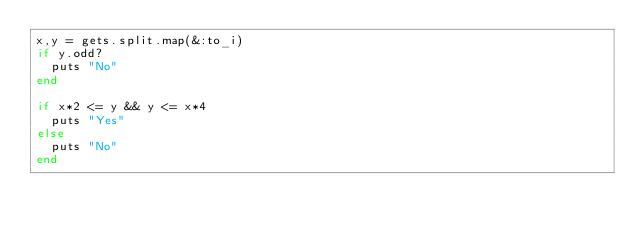Convert code to text. <code><loc_0><loc_0><loc_500><loc_500><_Ruby_>x,y = gets.split.map(&:to_i)
if y.odd?
  puts "No"
end

if x*2 <= y && y <= x*4
  puts "Yes"
else
  puts "No"
end
</code> 